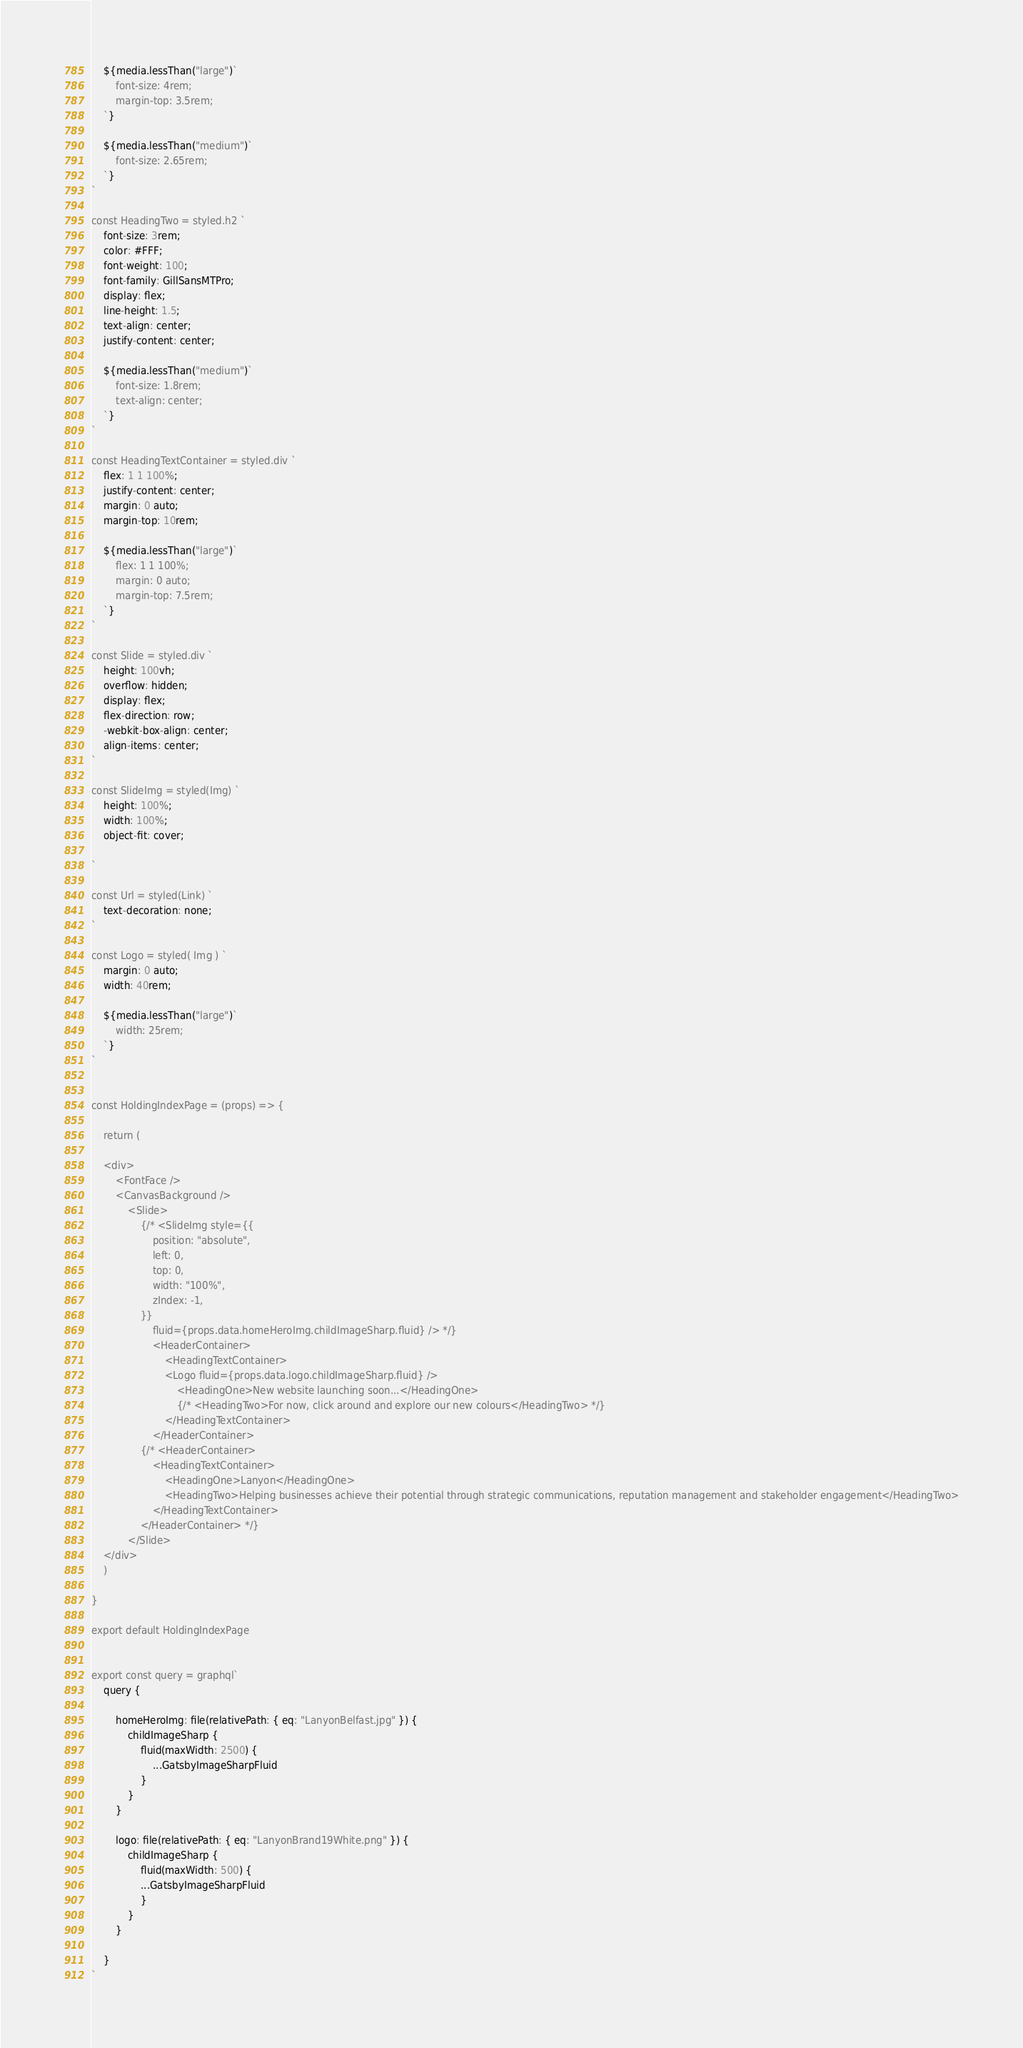Convert code to text. <code><loc_0><loc_0><loc_500><loc_500><_JavaScript_>    ${media.lessThan("large")`
        font-size: 4rem;
        margin-top: 3.5rem;
    `}

    ${media.lessThan("medium")`
        font-size: 2.65rem;
    `}
`

const HeadingTwo = styled.h2 `
    font-size: 3rem;
    color: #FFF;
    font-weight: 100;
    font-family: GillSansMTPro;
    display: flex;
    line-height: 1.5;
    text-align: center;
    justify-content: center;

    ${media.lessThan("medium")`
        font-size: 1.8rem; 
        text-align: center;
    `}
`

const HeadingTextContainer = styled.div `
    flex: 1 1 100%;
    justify-content: center;
    margin: 0 auto;
    margin-top: 10rem;

    ${media.lessThan("large")`
        flex: 1 1 100%;
        margin: 0 auto;
        margin-top: 7.5rem;
    `}
`

const Slide = styled.div `
    height: 100vh;
    overflow: hidden;
    display: flex;
    flex-direction: row;
    -webkit-box-align: center;
    align-items: center;
`

const SlideImg = styled(Img) `
    height: 100%;
    width: 100%;
    object-fit: cover;
    
`

const Url = styled(Link) `
    text-decoration: none;
`

const Logo = styled( Img ) `
    margin: 0 auto;
    width: 40rem;

    ${media.lessThan("large")`
        width: 25rem;
    `}
`


const HoldingIndexPage = (props) => {

    return (

    <div>
        <FontFace />
        <CanvasBackground />
            <Slide>
                {/* <SlideImg style={{
                    position: "absolute",
                    left: 0,
                    top: 0,
                    width: "100%",
                    zIndex: -1,
                }}
                    fluid={props.data.homeHeroImg.childImageSharp.fluid} /> */}
                    <HeaderContainer>
                        <HeadingTextContainer>
                        <Logo fluid={props.data.logo.childImageSharp.fluid} />
                            <HeadingOne>New website launching soon...</HeadingOne>
                            {/* <HeadingTwo>For now, click around and explore our new colours</HeadingTwo> */}
                        </HeadingTextContainer>
                    </HeaderContainer>
                {/* <HeaderContainer>
                    <HeadingTextContainer>
                        <HeadingOne>Lanyon</HeadingOne>
                        <HeadingTwo>Helping businesses achieve their potential through strategic communications, reputation management and stakeholder engagement</HeadingTwo>
                    </HeadingTextContainer>
                </HeaderContainer> */}
            </Slide>
    </div>
    )

}

export default HoldingIndexPage


export const query = graphql`
    query {

        homeHeroImg: file(relativePath: { eq: "LanyonBelfast.jpg" }) {
            childImageSharp {
                fluid(maxWidth: 2500) {
                    ...GatsbyImageSharpFluid
                }
            }
        }

        logo: file(relativePath: { eq: "LanyonBrand19White.png" }) {
            childImageSharp {
                fluid(maxWidth: 500) {
                ...GatsbyImageSharpFluid
                }
            }
        }

    }
`</code> 